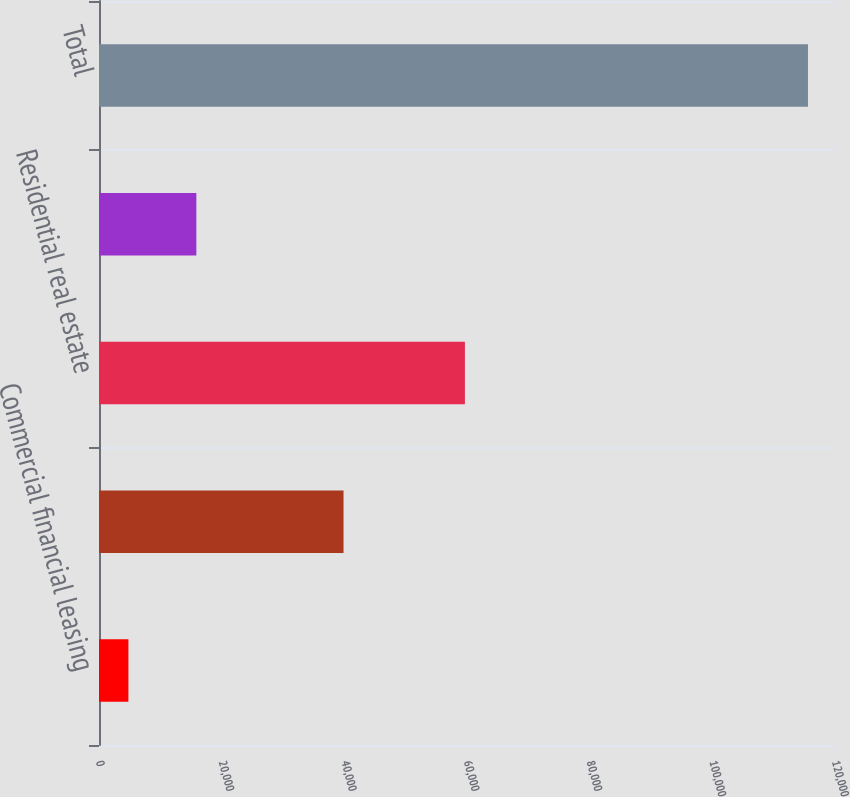<chart> <loc_0><loc_0><loc_500><loc_500><bar_chart><fcel>Commercial financial leasing<fcel>Commercial real estate<fcel>Residential real estate<fcel>Consumer<fcel>Total<nl><fcel>4794<fcel>39867<fcel>59657<fcel>15873.9<fcel>115593<nl></chart> 